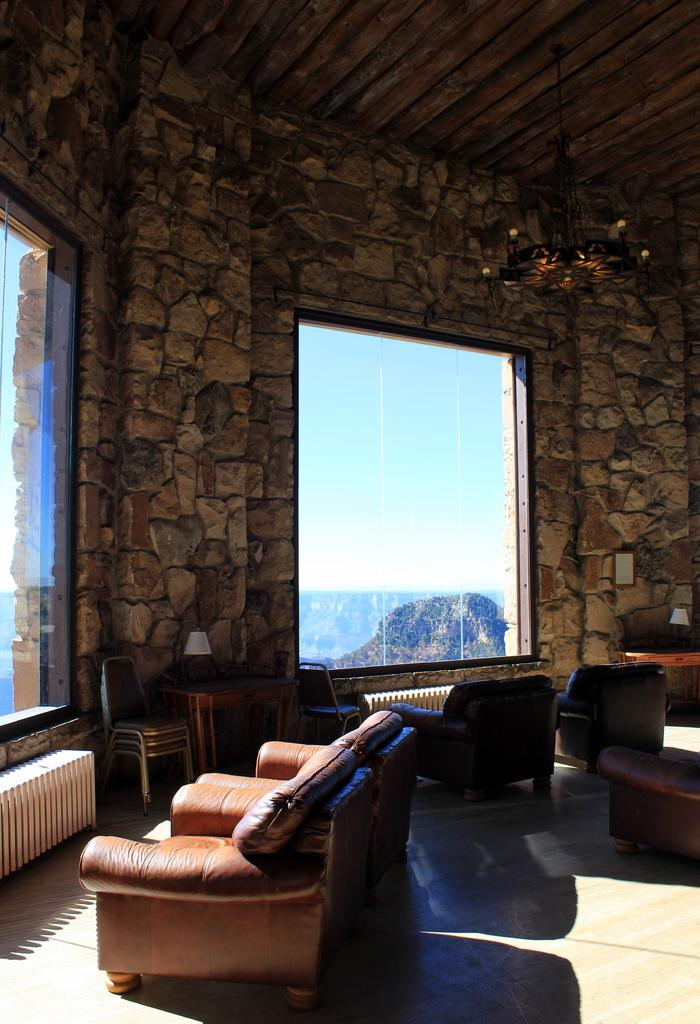What type of furniture is in the room? There is a sofa, a table, and chairs in the room. What is used for lighting in the room? There is a lamp in the room for lighting. How can natural light enter the room? There are windows in the room for natural light to enter. What is on the wall in the room? There are frames on the wall. What is the surface that people walk on in the room? There is a floor in the room. What type of science experiment is being conducted in the room? There is no indication of a science experiment being conducted in the room; the image only shows furniture, lighting, windows, frames, and a floor. 